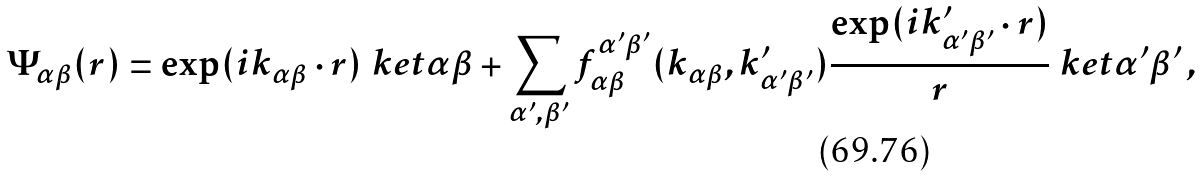Convert formula to latex. <formula><loc_0><loc_0><loc_500><loc_500>\Psi _ { \alpha \beta } ( { r } ) = \exp ( { i { k } _ { \alpha \beta } \cdot { r } } ) \ k e t { \alpha \beta } + \sum _ { \alpha ^ { \prime } , \beta ^ { \prime } } f _ { \alpha \beta } ^ { \alpha ^ { \prime } \beta ^ { \prime } } ( { k } _ { \alpha \beta } , { k } ^ { \prime } _ { \alpha ^ { \prime } \beta ^ { \prime } } ) \frac { \exp ( { i { k } ^ { \prime } _ { \alpha ^ { \prime } \beta ^ { \prime } } \cdot { r } } ) } { r } \ k e t { \alpha ^ { \prime } \beta ^ { \prime } } \, ,</formula> 